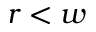<formula> <loc_0><loc_0><loc_500><loc_500>r < w</formula> 